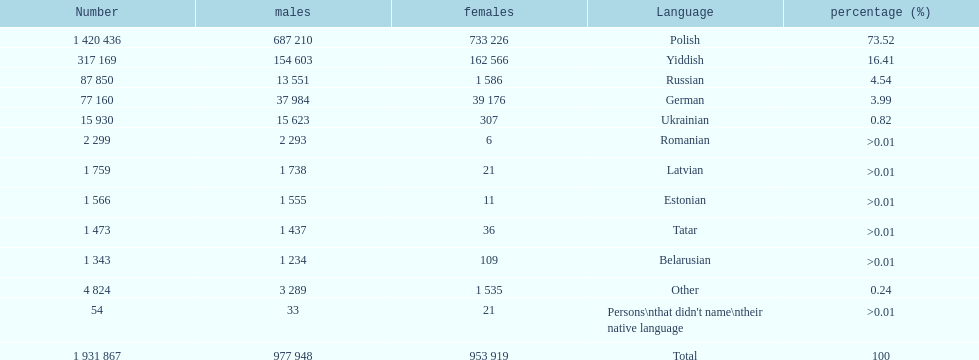Is german above or below russia in the number of people who speak that language? Below. 